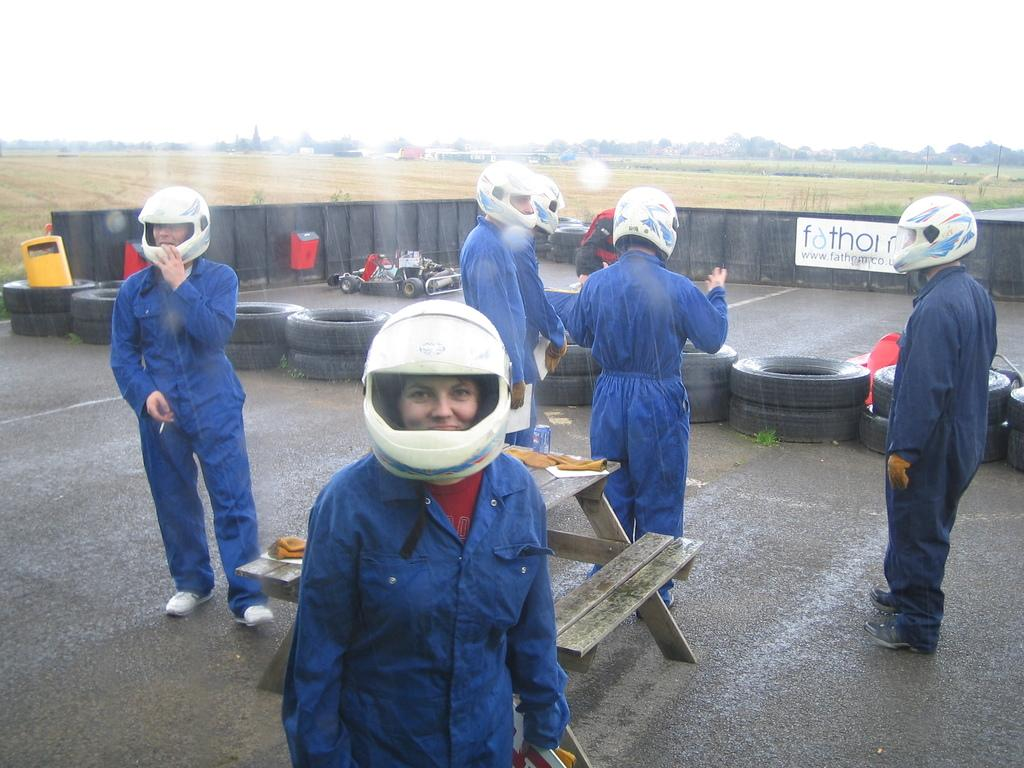What type of setting is depicted in the image? There is an open area in the image. How many people are present in the image? There are four people standing in the image. What are the people wearing? The people are wearing uniforms and helmets on their heads. What piece of furniture can be seen in the image? There is a bench in the image. What type of vehicle is parked on the road in the image? There is a sports car parked on the road in the image. What type of medical procedure is the doctor performing on the club in the image? There is no doctor or club present in the image. 